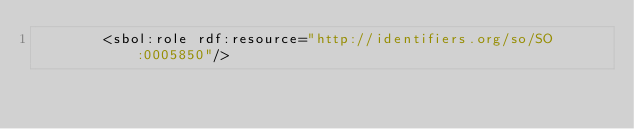Convert code to text. <code><loc_0><loc_0><loc_500><loc_500><_XML_>        <sbol:role rdf:resource="http://identifiers.org/so/SO:0005850"/></code> 